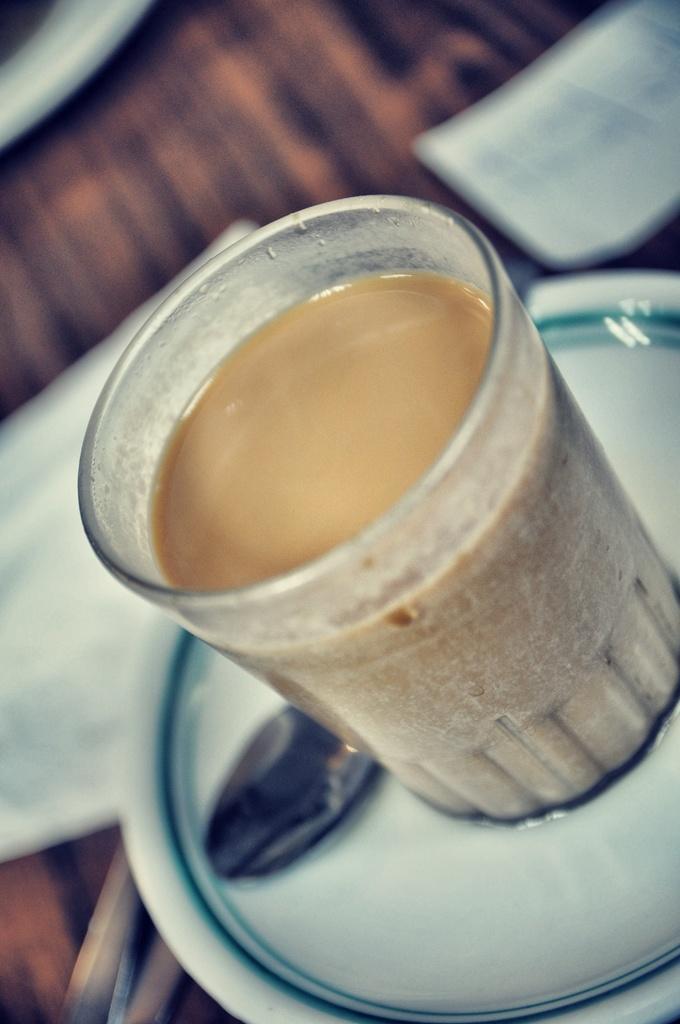Can you describe this image briefly? Here is a tea in the glass and the glass on the plate which also have a spoon. 